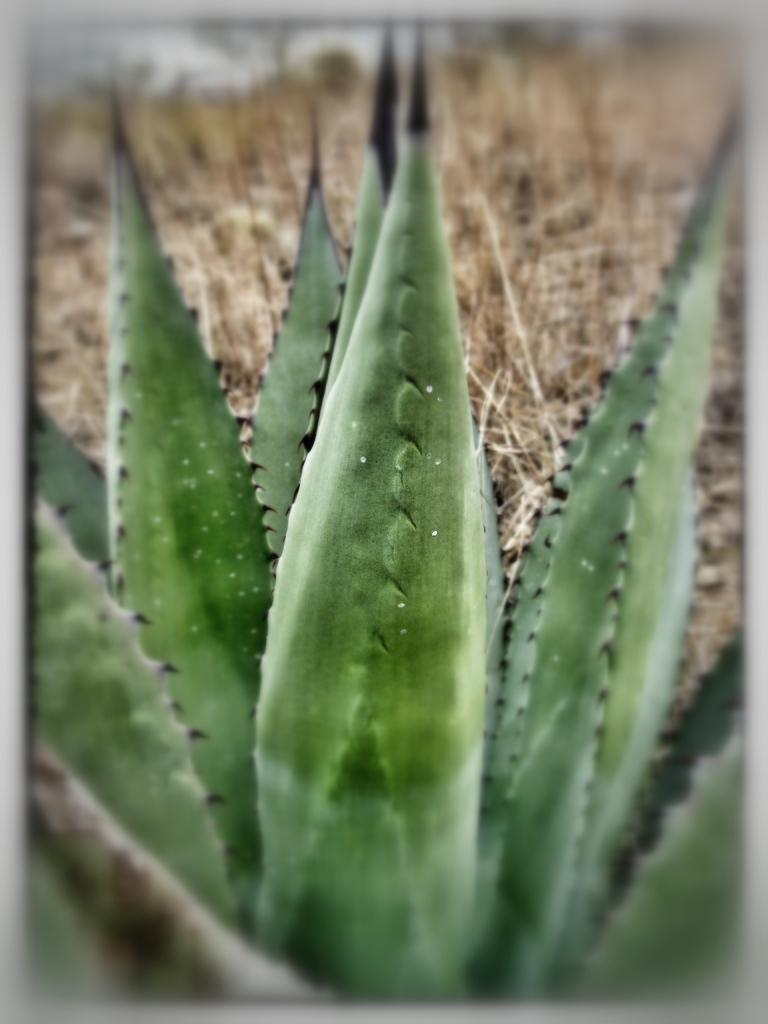What type of living organism can be seen in the image? There is a plant in the image. What is the condition of the vegetation behind the plant? There is dry grass visible behind the plant. How many cars can be seen flying with wings in the image? There are no cars or wings present in the image; it features a plant and dry grass. 